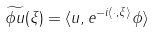<formula> <loc_0><loc_0><loc_500><loc_500>\widetilde { \phi u } ( \xi ) = \langle u , e ^ { - i \langle \cdot , \xi \rangle } \phi \rangle</formula> 